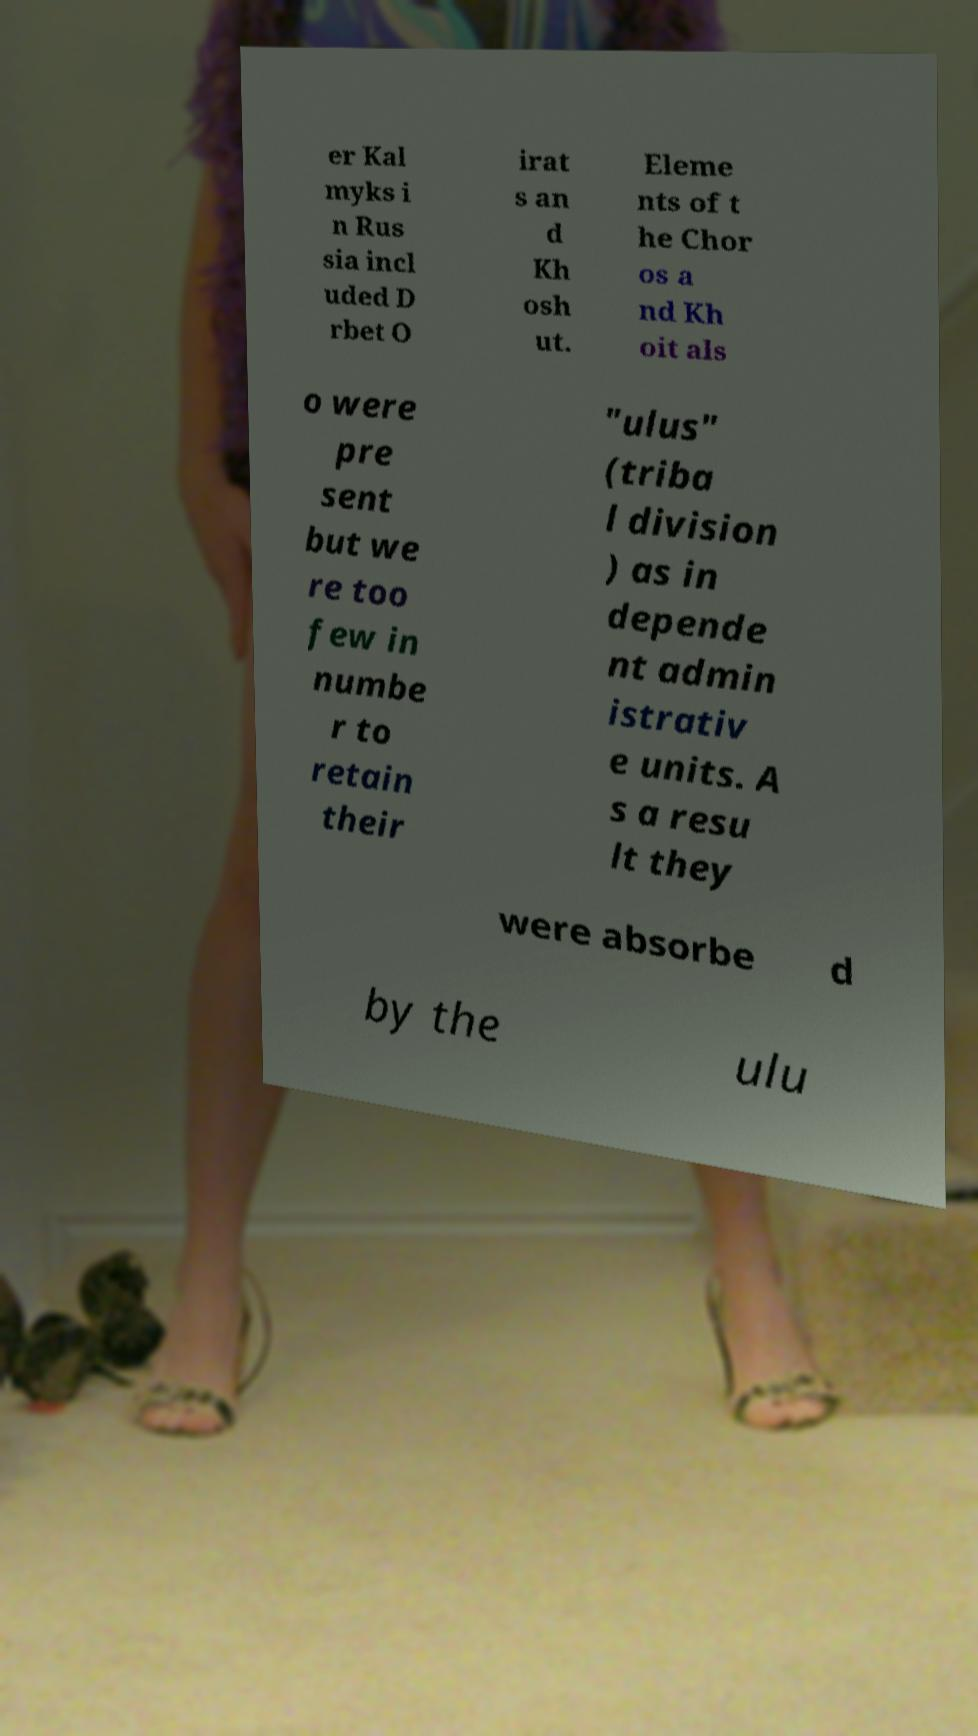Please identify and transcribe the text found in this image. er Kal myks i n Rus sia incl uded D rbet O irat s an d Kh osh ut. Eleme nts of t he Chor os a nd Kh oit als o were pre sent but we re too few in numbe r to retain their "ulus" (triba l division ) as in depende nt admin istrativ e units. A s a resu lt they were absorbe d by the ulu 